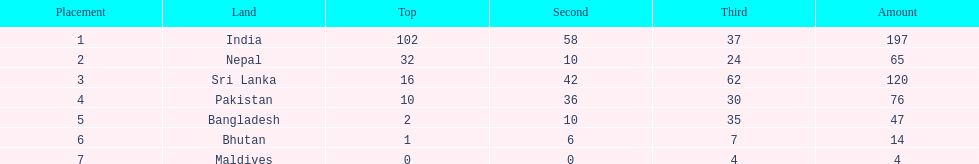How many more gold medals has nepal won than pakistan? 22. 